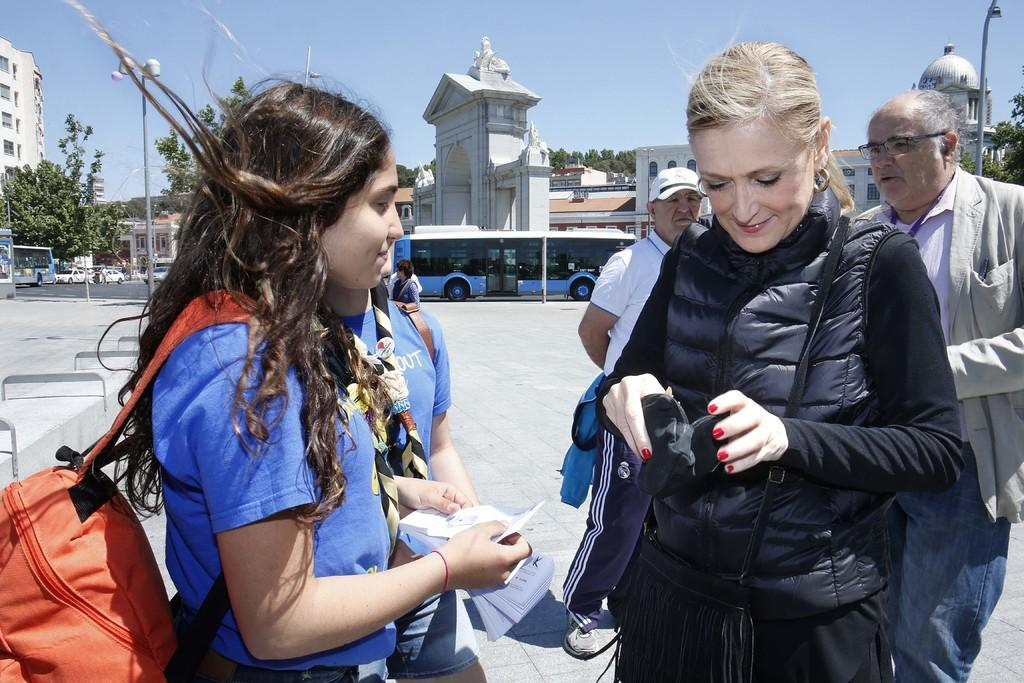What can be seen on the road in the image? There are persons and vehicles on the road in the image. What else is visible in the image besides the road? There are poles, trees, buildings, and the sky visible in the image. Can you describe the surroundings of the road? The surroundings of the road include trees, buildings, and poles. What is visible in the background of the image? The sky is visible in the background of the image. What type of land can be seen in the image? The image does not depict a specific type of land; it shows a road with various elements around it. 